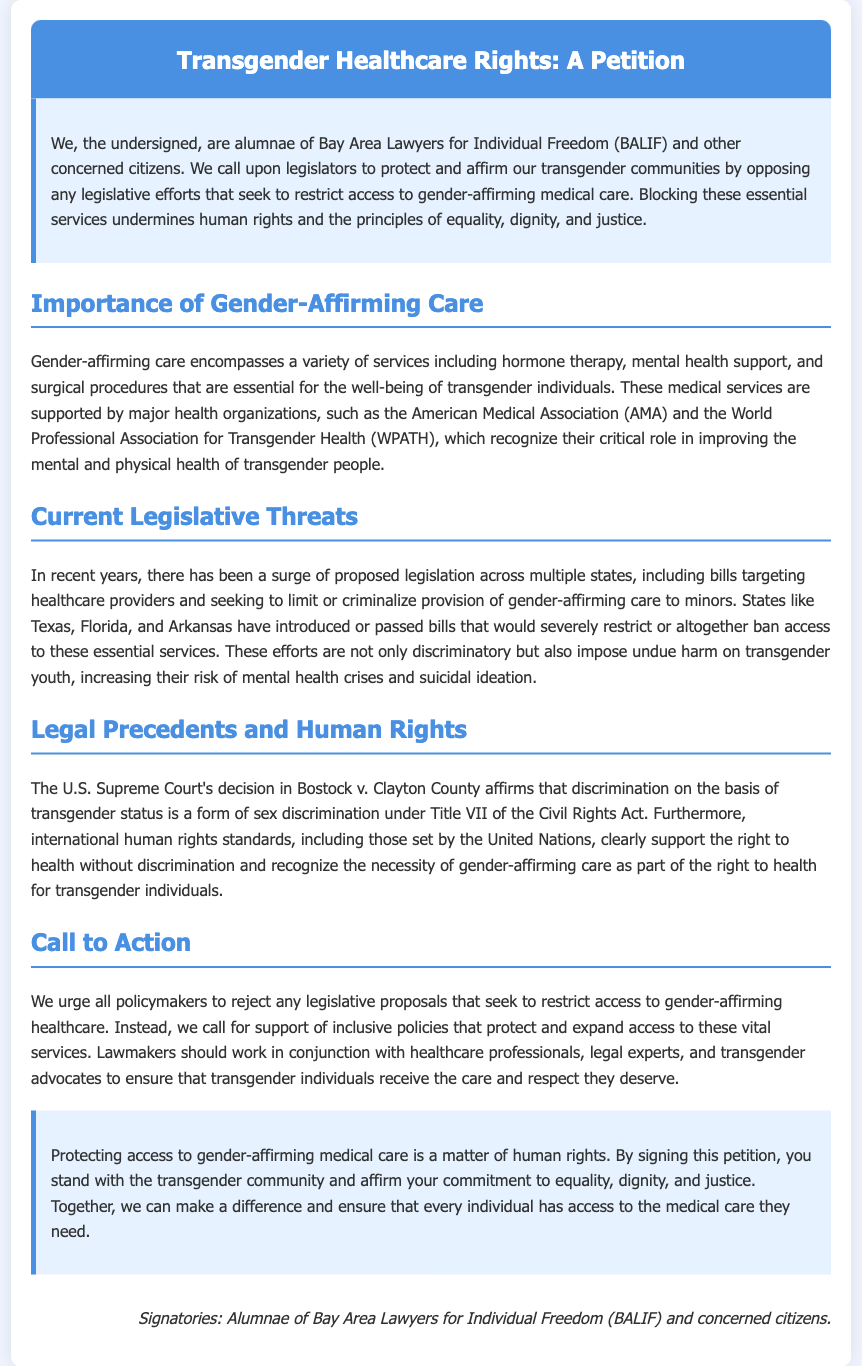what is the title of the petition? The title of the petition is included in the header section as the main heading of the document.
Answer: Transgender Healthcare Rights: A Petition who are the signatories of the petition? The signatories are mentioned at the end of the document under the signature section.
Answer: Alumnae of Bay Area Lawyers for Individual Freedom (BALIF) and concerned citizens which states have introduced or passed bills restricting gender-affirming care? The document lists specific states that have taken such legislative actions in the section discussing current threats.
Answer: Texas, Florida, Arkansas what year was the Bostock v. Clayton County decision made? The document references the decision but does not specify the year. A brief external knowledge check reveals this information.
Answer: 2020 what do major health organizations say about gender-affirming care? The document supports the importance of gender-affirming care by citing major health organizations’ stance in the section on importance.
Answer: Supported what is the primary call to action in the petition? The main message in the call to action section urges policymakers to take specific actions regarding healthcare legislation.
Answer: Reject legislative proposals how is gender-affirming care described in the petition? The introduction to the importance section outlines the services included in gender-affirming care.
Answer: A variety of services including hormone therapy, mental health support, and surgical procedures what is the background color of the document? The background color, which is specified in the style section of the document, sets the visual tone for the entire document.
Answer: Light blue (f0f5ff) 